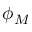Convert formula to latex. <formula><loc_0><loc_0><loc_500><loc_500>\phi _ { M }</formula> 